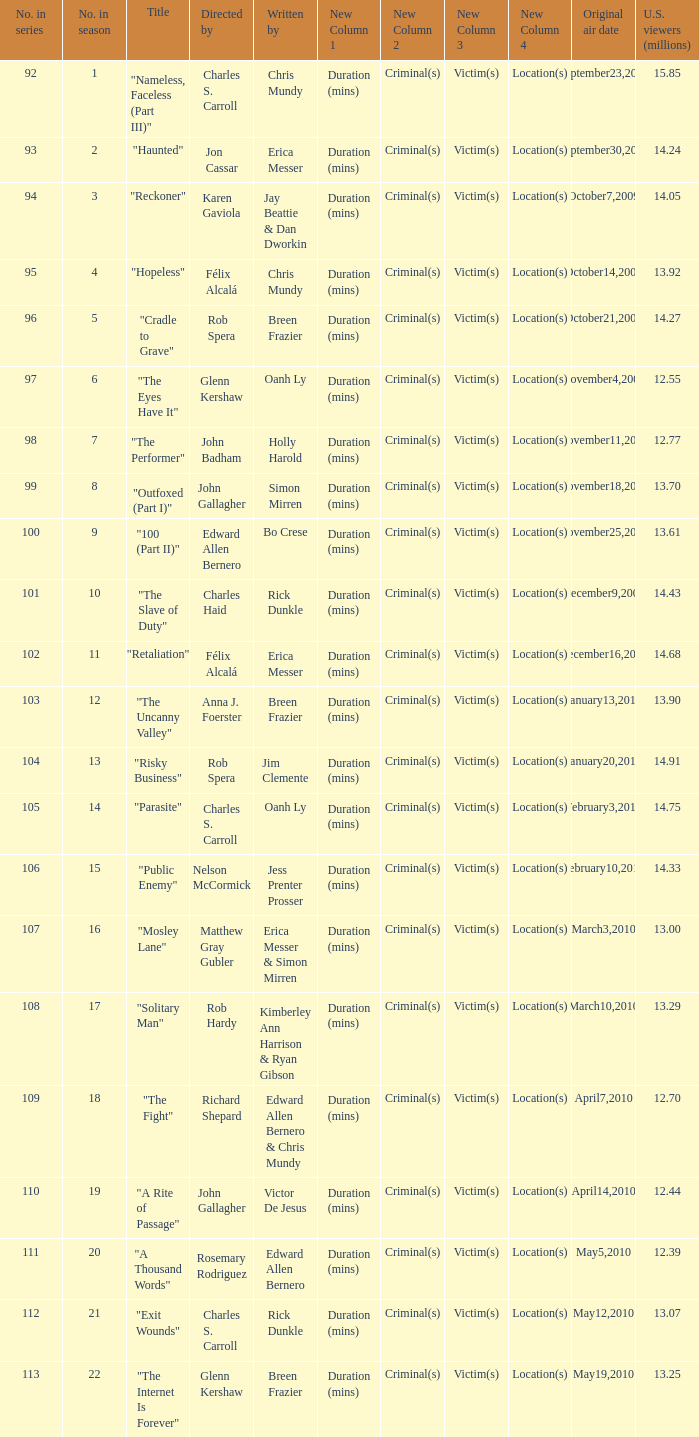What was the original air date for the episode with 13.92 million us viewers? October14,2009. 